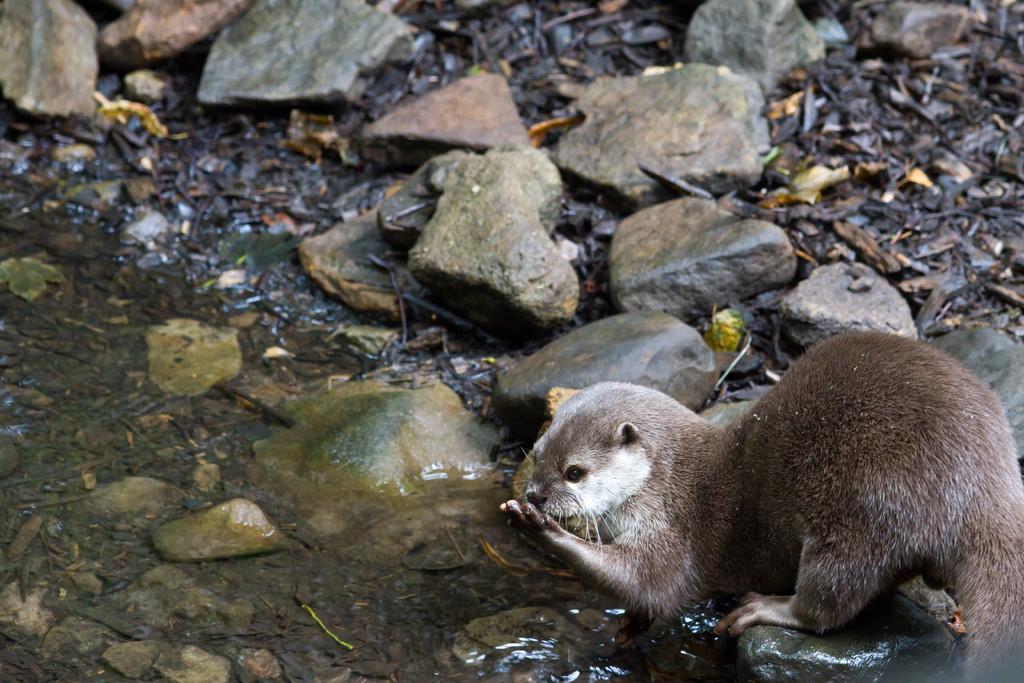Describe this image in one or two sentences. In this image there is a water towards the bottom of the image, there is an Otter, there are rocks on the ground, there are dried leaves on the ground. 